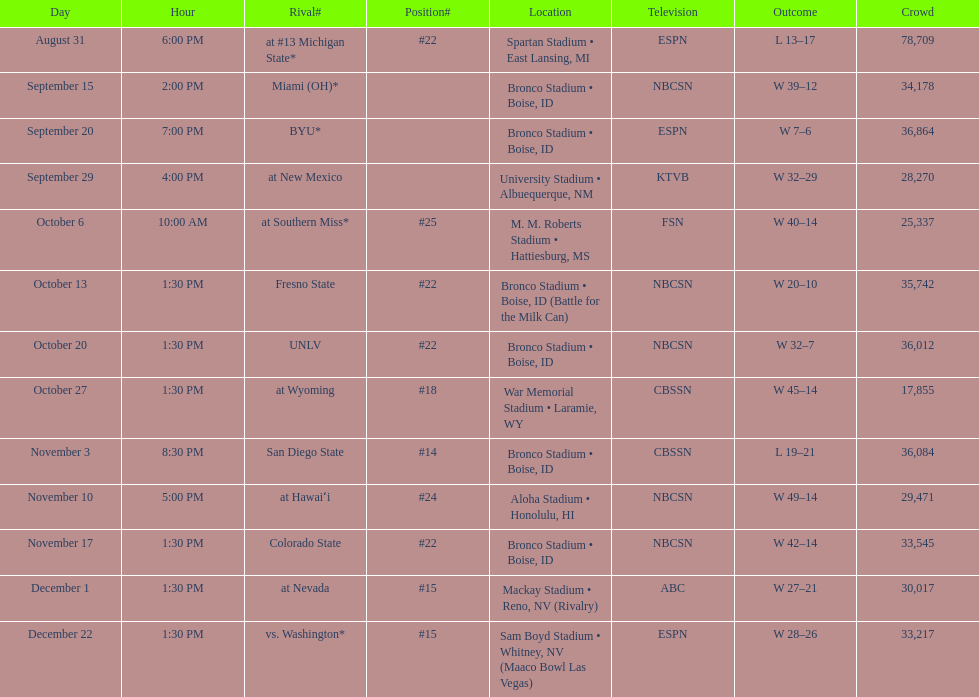What was there top ranked position of the season? #14. 